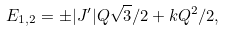<formula> <loc_0><loc_0><loc_500><loc_500>E _ { 1 , 2 } = \pm | J ^ { \prime } | Q \sqrt { 3 } / 2 + k Q ^ { 2 } / 2 ,</formula> 